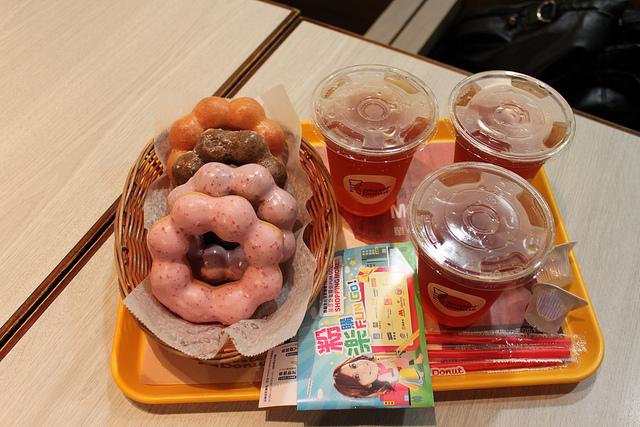How many cups are on the tray?
Keep it brief. 3. How many plates are here?
Write a very short answer. 1. What do the English words say on the paper in front?
Keep it brief. Fun go!. Are there any straws on the plate?
Concise answer only. Yes. 